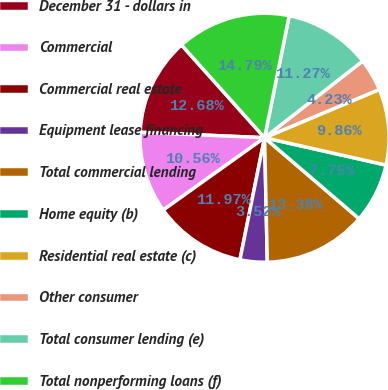Convert chart. <chart><loc_0><loc_0><loc_500><loc_500><pie_chart><fcel>December 31 - dollars in<fcel>Commercial<fcel>Commercial real estate<fcel>Equipment lease financing<fcel>Total commercial lending<fcel>Home equity (b)<fcel>Residential real estate (c)<fcel>Other consumer<fcel>Total consumer lending (e)<fcel>Total nonperforming loans (f)<nl><fcel>12.68%<fcel>10.56%<fcel>11.97%<fcel>3.52%<fcel>13.38%<fcel>7.75%<fcel>9.86%<fcel>4.23%<fcel>11.27%<fcel>14.79%<nl></chart> 